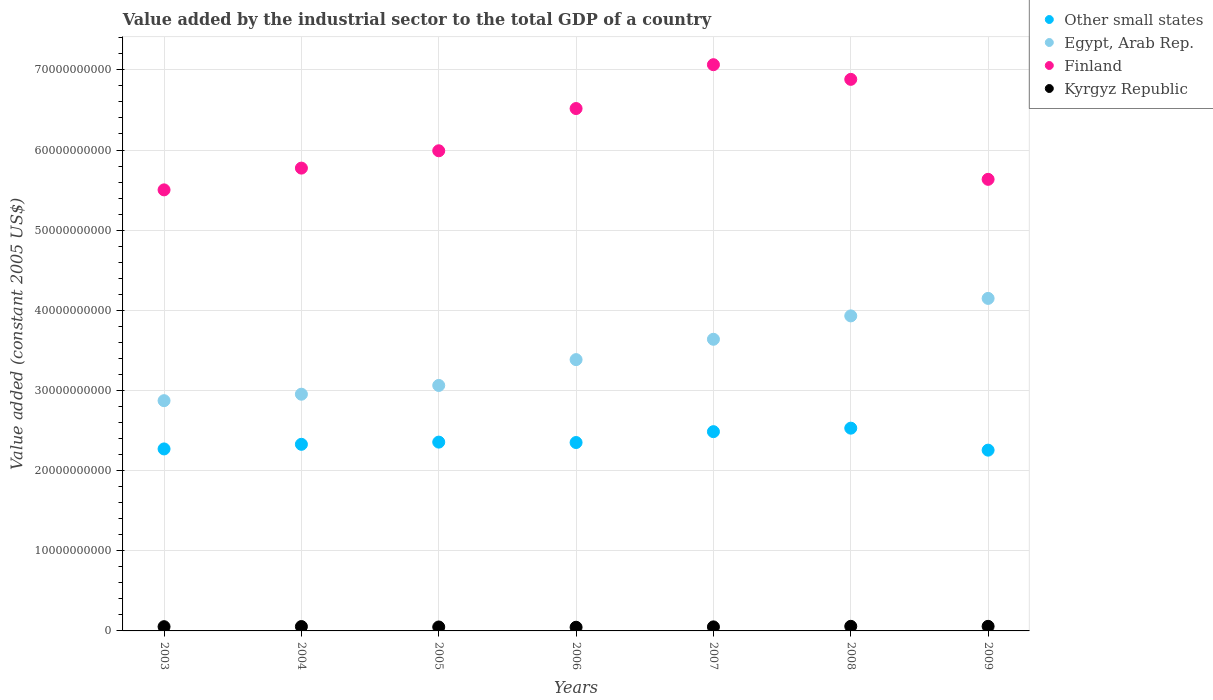How many different coloured dotlines are there?
Make the answer very short. 4. Is the number of dotlines equal to the number of legend labels?
Make the answer very short. Yes. What is the value added by the industrial sector in Other small states in 2008?
Offer a very short reply. 2.53e+1. Across all years, what is the maximum value added by the industrial sector in Other small states?
Offer a terse response. 2.53e+1. Across all years, what is the minimum value added by the industrial sector in Other small states?
Ensure brevity in your answer.  2.26e+1. What is the total value added by the industrial sector in Other small states in the graph?
Make the answer very short. 1.66e+11. What is the difference between the value added by the industrial sector in Egypt, Arab Rep. in 2003 and that in 2008?
Ensure brevity in your answer.  -1.06e+1. What is the difference between the value added by the industrial sector in Egypt, Arab Rep. in 2007 and the value added by the industrial sector in Finland in 2008?
Keep it short and to the point. -3.24e+1. What is the average value added by the industrial sector in Other small states per year?
Ensure brevity in your answer.  2.37e+1. In the year 2003, what is the difference between the value added by the industrial sector in Other small states and value added by the industrial sector in Finland?
Keep it short and to the point. -3.23e+1. In how many years, is the value added by the industrial sector in Other small states greater than 50000000000 US$?
Offer a very short reply. 0. What is the ratio of the value added by the industrial sector in Egypt, Arab Rep. in 2004 to that in 2007?
Your answer should be compact. 0.81. What is the difference between the highest and the second highest value added by the industrial sector in Egypt, Arab Rep.?
Your response must be concise. 2.18e+09. What is the difference between the highest and the lowest value added by the industrial sector in Finland?
Your answer should be compact. 1.56e+1. In how many years, is the value added by the industrial sector in Finland greater than the average value added by the industrial sector in Finland taken over all years?
Your response must be concise. 3. Is it the case that in every year, the sum of the value added by the industrial sector in Finland and value added by the industrial sector in Other small states  is greater than the sum of value added by the industrial sector in Egypt, Arab Rep. and value added by the industrial sector in Kyrgyz Republic?
Your answer should be very brief. No. Does the value added by the industrial sector in Other small states monotonically increase over the years?
Offer a very short reply. No. What is the difference between two consecutive major ticks on the Y-axis?
Offer a terse response. 1.00e+1. Are the values on the major ticks of Y-axis written in scientific E-notation?
Your answer should be very brief. No. Does the graph contain any zero values?
Give a very brief answer. No. Does the graph contain grids?
Keep it short and to the point. Yes. How are the legend labels stacked?
Your answer should be very brief. Vertical. What is the title of the graph?
Your response must be concise. Value added by the industrial sector to the total GDP of a country. What is the label or title of the X-axis?
Your response must be concise. Years. What is the label or title of the Y-axis?
Ensure brevity in your answer.  Value added (constant 2005 US$). What is the Value added (constant 2005 US$) of Other small states in 2003?
Offer a terse response. 2.27e+1. What is the Value added (constant 2005 US$) in Egypt, Arab Rep. in 2003?
Provide a short and direct response. 2.87e+1. What is the Value added (constant 2005 US$) of Finland in 2003?
Your answer should be compact. 5.50e+1. What is the Value added (constant 2005 US$) of Kyrgyz Republic in 2003?
Your response must be concise. 5.29e+08. What is the Value added (constant 2005 US$) of Other small states in 2004?
Your answer should be very brief. 2.33e+1. What is the Value added (constant 2005 US$) of Egypt, Arab Rep. in 2004?
Keep it short and to the point. 2.95e+1. What is the Value added (constant 2005 US$) of Finland in 2004?
Keep it short and to the point. 5.77e+1. What is the Value added (constant 2005 US$) in Kyrgyz Republic in 2004?
Ensure brevity in your answer.  5.45e+08. What is the Value added (constant 2005 US$) of Other small states in 2005?
Offer a very short reply. 2.36e+1. What is the Value added (constant 2005 US$) in Egypt, Arab Rep. in 2005?
Your response must be concise. 3.06e+1. What is the Value added (constant 2005 US$) of Finland in 2005?
Give a very brief answer. 5.99e+1. What is the Value added (constant 2005 US$) of Kyrgyz Republic in 2005?
Provide a succinct answer. 4.91e+08. What is the Value added (constant 2005 US$) of Other small states in 2006?
Offer a very short reply. 2.35e+1. What is the Value added (constant 2005 US$) in Egypt, Arab Rep. in 2006?
Your answer should be compact. 3.38e+1. What is the Value added (constant 2005 US$) of Finland in 2006?
Offer a terse response. 6.52e+1. What is the Value added (constant 2005 US$) of Kyrgyz Republic in 2006?
Make the answer very short. 4.57e+08. What is the Value added (constant 2005 US$) in Other small states in 2007?
Offer a terse response. 2.49e+1. What is the Value added (constant 2005 US$) in Egypt, Arab Rep. in 2007?
Offer a very short reply. 3.64e+1. What is the Value added (constant 2005 US$) of Finland in 2007?
Provide a short and direct response. 7.06e+1. What is the Value added (constant 2005 US$) in Kyrgyz Republic in 2007?
Provide a short and direct response. 5.04e+08. What is the Value added (constant 2005 US$) of Other small states in 2008?
Your answer should be compact. 2.53e+1. What is the Value added (constant 2005 US$) in Egypt, Arab Rep. in 2008?
Your response must be concise. 3.93e+1. What is the Value added (constant 2005 US$) in Finland in 2008?
Offer a terse response. 6.88e+1. What is the Value added (constant 2005 US$) in Kyrgyz Republic in 2008?
Provide a succinct answer. 5.74e+08. What is the Value added (constant 2005 US$) of Other small states in 2009?
Offer a terse response. 2.26e+1. What is the Value added (constant 2005 US$) in Egypt, Arab Rep. in 2009?
Keep it short and to the point. 4.15e+1. What is the Value added (constant 2005 US$) in Finland in 2009?
Your answer should be very brief. 5.63e+1. What is the Value added (constant 2005 US$) in Kyrgyz Republic in 2009?
Your answer should be compact. 5.72e+08. Across all years, what is the maximum Value added (constant 2005 US$) in Other small states?
Your answer should be very brief. 2.53e+1. Across all years, what is the maximum Value added (constant 2005 US$) in Egypt, Arab Rep.?
Provide a succinct answer. 4.15e+1. Across all years, what is the maximum Value added (constant 2005 US$) of Finland?
Your answer should be very brief. 7.06e+1. Across all years, what is the maximum Value added (constant 2005 US$) in Kyrgyz Republic?
Your response must be concise. 5.74e+08. Across all years, what is the minimum Value added (constant 2005 US$) in Other small states?
Your response must be concise. 2.26e+1. Across all years, what is the minimum Value added (constant 2005 US$) in Egypt, Arab Rep.?
Your answer should be compact. 2.87e+1. Across all years, what is the minimum Value added (constant 2005 US$) of Finland?
Provide a short and direct response. 5.50e+1. Across all years, what is the minimum Value added (constant 2005 US$) in Kyrgyz Republic?
Give a very brief answer. 4.57e+08. What is the total Value added (constant 2005 US$) of Other small states in the graph?
Make the answer very short. 1.66e+11. What is the total Value added (constant 2005 US$) in Egypt, Arab Rep. in the graph?
Ensure brevity in your answer.  2.40e+11. What is the total Value added (constant 2005 US$) in Finland in the graph?
Ensure brevity in your answer.  4.34e+11. What is the total Value added (constant 2005 US$) in Kyrgyz Republic in the graph?
Offer a terse response. 3.67e+09. What is the difference between the Value added (constant 2005 US$) in Other small states in 2003 and that in 2004?
Provide a succinct answer. -5.76e+08. What is the difference between the Value added (constant 2005 US$) in Egypt, Arab Rep. in 2003 and that in 2004?
Your answer should be very brief. -8.06e+08. What is the difference between the Value added (constant 2005 US$) of Finland in 2003 and that in 2004?
Your response must be concise. -2.71e+09. What is the difference between the Value added (constant 2005 US$) of Kyrgyz Republic in 2003 and that in 2004?
Provide a short and direct response. -1.61e+07. What is the difference between the Value added (constant 2005 US$) of Other small states in 2003 and that in 2005?
Offer a terse response. -8.50e+08. What is the difference between the Value added (constant 2005 US$) of Egypt, Arab Rep. in 2003 and that in 2005?
Provide a succinct answer. -1.90e+09. What is the difference between the Value added (constant 2005 US$) in Finland in 2003 and that in 2005?
Give a very brief answer. -4.88e+09. What is the difference between the Value added (constant 2005 US$) of Kyrgyz Republic in 2003 and that in 2005?
Provide a succinct answer. 3.76e+07. What is the difference between the Value added (constant 2005 US$) of Other small states in 2003 and that in 2006?
Make the answer very short. -7.98e+08. What is the difference between the Value added (constant 2005 US$) in Egypt, Arab Rep. in 2003 and that in 2006?
Your answer should be very brief. -5.12e+09. What is the difference between the Value added (constant 2005 US$) in Finland in 2003 and that in 2006?
Offer a terse response. -1.01e+1. What is the difference between the Value added (constant 2005 US$) of Kyrgyz Republic in 2003 and that in 2006?
Provide a succinct answer. 7.22e+07. What is the difference between the Value added (constant 2005 US$) of Other small states in 2003 and that in 2007?
Your answer should be very brief. -2.15e+09. What is the difference between the Value added (constant 2005 US$) of Egypt, Arab Rep. in 2003 and that in 2007?
Keep it short and to the point. -7.66e+09. What is the difference between the Value added (constant 2005 US$) in Finland in 2003 and that in 2007?
Provide a succinct answer. -1.56e+1. What is the difference between the Value added (constant 2005 US$) of Kyrgyz Republic in 2003 and that in 2007?
Make the answer very short. 2.52e+07. What is the difference between the Value added (constant 2005 US$) of Other small states in 2003 and that in 2008?
Give a very brief answer. -2.59e+09. What is the difference between the Value added (constant 2005 US$) in Egypt, Arab Rep. in 2003 and that in 2008?
Provide a short and direct response. -1.06e+1. What is the difference between the Value added (constant 2005 US$) in Finland in 2003 and that in 2008?
Give a very brief answer. -1.38e+1. What is the difference between the Value added (constant 2005 US$) in Kyrgyz Republic in 2003 and that in 2008?
Give a very brief answer. -4.51e+07. What is the difference between the Value added (constant 2005 US$) of Other small states in 2003 and that in 2009?
Provide a succinct answer. 1.52e+08. What is the difference between the Value added (constant 2005 US$) in Egypt, Arab Rep. in 2003 and that in 2009?
Ensure brevity in your answer.  -1.28e+1. What is the difference between the Value added (constant 2005 US$) of Finland in 2003 and that in 2009?
Give a very brief answer. -1.31e+09. What is the difference between the Value added (constant 2005 US$) in Kyrgyz Republic in 2003 and that in 2009?
Your answer should be compact. -4.33e+07. What is the difference between the Value added (constant 2005 US$) of Other small states in 2004 and that in 2005?
Ensure brevity in your answer.  -2.73e+08. What is the difference between the Value added (constant 2005 US$) of Egypt, Arab Rep. in 2004 and that in 2005?
Your answer should be compact. -1.09e+09. What is the difference between the Value added (constant 2005 US$) in Finland in 2004 and that in 2005?
Provide a succinct answer. -2.16e+09. What is the difference between the Value added (constant 2005 US$) in Kyrgyz Republic in 2004 and that in 2005?
Your answer should be compact. 5.37e+07. What is the difference between the Value added (constant 2005 US$) of Other small states in 2004 and that in 2006?
Provide a short and direct response. -2.22e+08. What is the difference between the Value added (constant 2005 US$) in Egypt, Arab Rep. in 2004 and that in 2006?
Your answer should be very brief. -4.32e+09. What is the difference between the Value added (constant 2005 US$) in Finland in 2004 and that in 2006?
Make the answer very short. -7.43e+09. What is the difference between the Value added (constant 2005 US$) in Kyrgyz Republic in 2004 and that in 2006?
Your answer should be compact. 8.83e+07. What is the difference between the Value added (constant 2005 US$) of Other small states in 2004 and that in 2007?
Keep it short and to the point. -1.58e+09. What is the difference between the Value added (constant 2005 US$) in Egypt, Arab Rep. in 2004 and that in 2007?
Your answer should be compact. -6.85e+09. What is the difference between the Value added (constant 2005 US$) of Finland in 2004 and that in 2007?
Make the answer very short. -1.29e+1. What is the difference between the Value added (constant 2005 US$) of Kyrgyz Republic in 2004 and that in 2007?
Provide a succinct answer. 4.13e+07. What is the difference between the Value added (constant 2005 US$) of Other small states in 2004 and that in 2008?
Your answer should be very brief. -2.01e+09. What is the difference between the Value added (constant 2005 US$) of Egypt, Arab Rep. in 2004 and that in 2008?
Make the answer very short. -9.77e+09. What is the difference between the Value added (constant 2005 US$) in Finland in 2004 and that in 2008?
Offer a terse response. -1.11e+1. What is the difference between the Value added (constant 2005 US$) of Kyrgyz Republic in 2004 and that in 2008?
Offer a very short reply. -2.90e+07. What is the difference between the Value added (constant 2005 US$) of Other small states in 2004 and that in 2009?
Your response must be concise. 7.29e+08. What is the difference between the Value added (constant 2005 US$) of Egypt, Arab Rep. in 2004 and that in 2009?
Offer a very short reply. -1.20e+1. What is the difference between the Value added (constant 2005 US$) in Finland in 2004 and that in 2009?
Make the answer very short. 1.40e+09. What is the difference between the Value added (constant 2005 US$) of Kyrgyz Republic in 2004 and that in 2009?
Ensure brevity in your answer.  -2.72e+07. What is the difference between the Value added (constant 2005 US$) of Other small states in 2005 and that in 2006?
Keep it short and to the point. 5.14e+07. What is the difference between the Value added (constant 2005 US$) of Egypt, Arab Rep. in 2005 and that in 2006?
Provide a succinct answer. -3.22e+09. What is the difference between the Value added (constant 2005 US$) of Finland in 2005 and that in 2006?
Provide a short and direct response. -5.27e+09. What is the difference between the Value added (constant 2005 US$) of Kyrgyz Republic in 2005 and that in 2006?
Your answer should be compact. 3.46e+07. What is the difference between the Value added (constant 2005 US$) of Other small states in 2005 and that in 2007?
Your answer should be very brief. -1.30e+09. What is the difference between the Value added (constant 2005 US$) in Egypt, Arab Rep. in 2005 and that in 2007?
Offer a very short reply. -5.76e+09. What is the difference between the Value added (constant 2005 US$) in Finland in 2005 and that in 2007?
Your answer should be very brief. -1.07e+1. What is the difference between the Value added (constant 2005 US$) of Kyrgyz Republic in 2005 and that in 2007?
Your answer should be very brief. -1.24e+07. What is the difference between the Value added (constant 2005 US$) in Other small states in 2005 and that in 2008?
Make the answer very short. -1.74e+09. What is the difference between the Value added (constant 2005 US$) of Egypt, Arab Rep. in 2005 and that in 2008?
Make the answer very short. -8.68e+09. What is the difference between the Value added (constant 2005 US$) of Finland in 2005 and that in 2008?
Keep it short and to the point. -8.91e+09. What is the difference between the Value added (constant 2005 US$) of Kyrgyz Republic in 2005 and that in 2008?
Your answer should be very brief. -8.27e+07. What is the difference between the Value added (constant 2005 US$) in Other small states in 2005 and that in 2009?
Provide a short and direct response. 1.00e+09. What is the difference between the Value added (constant 2005 US$) in Egypt, Arab Rep. in 2005 and that in 2009?
Give a very brief answer. -1.09e+1. What is the difference between the Value added (constant 2005 US$) in Finland in 2005 and that in 2009?
Make the answer very short. 3.56e+09. What is the difference between the Value added (constant 2005 US$) of Kyrgyz Republic in 2005 and that in 2009?
Your response must be concise. -8.08e+07. What is the difference between the Value added (constant 2005 US$) of Other small states in 2006 and that in 2007?
Offer a very short reply. -1.36e+09. What is the difference between the Value added (constant 2005 US$) of Egypt, Arab Rep. in 2006 and that in 2007?
Keep it short and to the point. -2.54e+09. What is the difference between the Value added (constant 2005 US$) of Finland in 2006 and that in 2007?
Provide a short and direct response. -5.47e+09. What is the difference between the Value added (constant 2005 US$) in Kyrgyz Republic in 2006 and that in 2007?
Provide a short and direct response. -4.70e+07. What is the difference between the Value added (constant 2005 US$) of Other small states in 2006 and that in 2008?
Provide a short and direct response. -1.79e+09. What is the difference between the Value added (constant 2005 US$) in Egypt, Arab Rep. in 2006 and that in 2008?
Provide a short and direct response. -5.46e+09. What is the difference between the Value added (constant 2005 US$) of Finland in 2006 and that in 2008?
Your answer should be very brief. -3.64e+09. What is the difference between the Value added (constant 2005 US$) of Kyrgyz Republic in 2006 and that in 2008?
Give a very brief answer. -1.17e+08. What is the difference between the Value added (constant 2005 US$) of Other small states in 2006 and that in 2009?
Give a very brief answer. 9.50e+08. What is the difference between the Value added (constant 2005 US$) in Egypt, Arab Rep. in 2006 and that in 2009?
Offer a very short reply. -7.64e+09. What is the difference between the Value added (constant 2005 US$) in Finland in 2006 and that in 2009?
Make the answer very short. 8.83e+09. What is the difference between the Value added (constant 2005 US$) of Kyrgyz Republic in 2006 and that in 2009?
Your answer should be very brief. -1.15e+08. What is the difference between the Value added (constant 2005 US$) of Other small states in 2007 and that in 2008?
Provide a succinct answer. -4.36e+08. What is the difference between the Value added (constant 2005 US$) in Egypt, Arab Rep. in 2007 and that in 2008?
Provide a succinct answer. -2.92e+09. What is the difference between the Value added (constant 2005 US$) of Finland in 2007 and that in 2008?
Offer a terse response. 1.83e+09. What is the difference between the Value added (constant 2005 US$) of Kyrgyz Republic in 2007 and that in 2008?
Offer a terse response. -7.03e+07. What is the difference between the Value added (constant 2005 US$) of Other small states in 2007 and that in 2009?
Make the answer very short. 2.31e+09. What is the difference between the Value added (constant 2005 US$) of Egypt, Arab Rep. in 2007 and that in 2009?
Provide a succinct answer. -5.10e+09. What is the difference between the Value added (constant 2005 US$) in Finland in 2007 and that in 2009?
Offer a terse response. 1.43e+1. What is the difference between the Value added (constant 2005 US$) in Kyrgyz Republic in 2007 and that in 2009?
Your answer should be very brief. -6.85e+07. What is the difference between the Value added (constant 2005 US$) of Other small states in 2008 and that in 2009?
Your response must be concise. 2.74e+09. What is the difference between the Value added (constant 2005 US$) of Egypt, Arab Rep. in 2008 and that in 2009?
Your answer should be very brief. -2.18e+09. What is the difference between the Value added (constant 2005 US$) of Finland in 2008 and that in 2009?
Keep it short and to the point. 1.25e+1. What is the difference between the Value added (constant 2005 US$) of Kyrgyz Republic in 2008 and that in 2009?
Ensure brevity in your answer.  1.82e+06. What is the difference between the Value added (constant 2005 US$) of Other small states in 2003 and the Value added (constant 2005 US$) of Egypt, Arab Rep. in 2004?
Offer a very short reply. -6.83e+09. What is the difference between the Value added (constant 2005 US$) of Other small states in 2003 and the Value added (constant 2005 US$) of Finland in 2004?
Offer a terse response. -3.50e+1. What is the difference between the Value added (constant 2005 US$) of Other small states in 2003 and the Value added (constant 2005 US$) of Kyrgyz Republic in 2004?
Offer a very short reply. 2.22e+1. What is the difference between the Value added (constant 2005 US$) of Egypt, Arab Rep. in 2003 and the Value added (constant 2005 US$) of Finland in 2004?
Offer a terse response. -2.90e+1. What is the difference between the Value added (constant 2005 US$) in Egypt, Arab Rep. in 2003 and the Value added (constant 2005 US$) in Kyrgyz Republic in 2004?
Offer a terse response. 2.82e+1. What is the difference between the Value added (constant 2005 US$) of Finland in 2003 and the Value added (constant 2005 US$) of Kyrgyz Republic in 2004?
Give a very brief answer. 5.45e+1. What is the difference between the Value added (constant 2005 US$) of Other small states in 2003 and the Value added (constant 2005 US$) of Egypt, Arab Rep. in 2005?
Ensure brevity in your answer.  -7.92e+09. What is the difference between the Value added (constant 2005 US$) in Other small states in 2003 and the Value added (constant 2005 US$) in Finland in 2005?
Ensure brevity in your answer.  -3.72e+1. What is the difference between the Value added (constant 2005 US$) of Other small states in 2003 and the Value added (constant 2005 US$) of Kyrgyz Republic in 2005?
Provide a short and direct response. 2.22e+1. What is the difference between the Value added (constant 2005 US$) in Egypt, Arab Rep. in 2003 and the Value added (constant 2005 US$) in Finland in 2005?
Your answer should be compact. -3.12e+1. What is the difference between the Value added (constant 2005 US$) in Egypt, Arab Rep. in 2003 and the Value added (constant 2005 US$) in Kyrgyz Republic in 2005?
Provide a succinct answer. 2.82e+1. What is the difference between the Value added (constant 2005 US$) of Finland in 2003 and the Value added (constant 2005 US$) of Kyrgyz Republic in 2005?
Make the answer very short. 5.45e+1. What is the difference between the Value added (constant 2005 US$) in Other small states in 2003 and the Value added (constant 2005 US$) in Egypt, Arab Rep. in 2006?
Your response must be concise. -1.11e+1. What is the difference between the Value added (constant 2005 US$) in Other small states in 2003 and the Value added (constant 2005 US$) in Finland in 2006?
Ensure brevity in your answer.  -4.25e+1. What is the difference between the Value added (constant 2005 US$) of Other small states in 2003 and the Value added (constant 2005 US$) of Kyrgyz Republic in 2006?
Offer a very short reply. 2.23e+1. What is the difference between the Value added (constant 2005 US$) in Egypt, Arab Rep. in 2003 and the Value added (constant 2005 US$) in Finland in 2006?
Your answer should be very brief. -3.64e+1. What is the difference between the Value added (constant 2005 US$) of Egypt, Arab Rep. in 2003 and the Value added (constant 2005 US$) of Kyrgyz Republic in 2006?
Your answer should be compact. 2.83e+1. What is the difference between the Value added (constant 2005 US$) of Finland in 2003 and the Value added (constant 2005 US$) of Kyrgyz Republic in 2006?
Offer a very short reply. 5.46e+1. What is the difference between the Value added (constant 2005 US$) in Other small states in 2003 and the Value added (constant 2005 US$) in Egypt, Arab Rep. in 2007?
Make the answer very short. -1.37e+1. What is the difference between the Value added (constant 2005 US$) in Other small states in 2003 and the Value added (constant 2005 US$) in Finland in 2007?
Keep it short and to the point. -4.79e+1. What is the difference between the Value added (constant 2005 US$) in Other small states in 2003 and the Value added (constant 2005 US$) in Kyrgyz Republic in 2007?
Make the answer very short. 2.22e+1. What is the difference between the Value added (constant 2005 US$) of Egypt, Arab Rep. in 2003 and the Value added (constant 2005 US$) of Finland in 2007?
Keep it short and to the point. -4.19e+1. What is the difference between the Value added (constant 2005 US$) in Egypt, Arab Rep. in 2003 and the Value added (constant 2005 US$) in Kyrgyz Republic in 2007?
Your answer should be very brief. 2.82e+1. What is the difference between the Value added (constant 2005 US$) of Finland in 2003 and the Value added (constant 2005 US$) of Kyrgyz Republic in 2007?
Provide a succinct answer. 5.45e+1. What is the difference between the Value added (constant 2005 US$) in Other small states in 2003 and the Value added (constant 2005 US$) in Egypt, Arab Rep. in 2008?
Give a very brief answer. -1.66e+1. What is the difference between the Value added (constant 2005 US$) in Other small states in 2003 and the Value added (constant 2005 US$) in Finland in 2008?
Make the answer very short. -4.61e+1. What is the difference between the Value added (constant 2005 US$) of Other small states in 2003 and the Value added (constant 2005 US$) of Kyrgyz Republic in 2008?
Your answer should be very brief. 2.21e+1. What is the difference between the Value added (constant 2005 US$) of Egypt, Arab Rep. in 2003 and the Value added (constant 2005 US$) of Finland in 2008?
Your answer should be very brief. -4.01e+1. What is the difference between the Value added (constant 2005 US$) of Egypt, Arab Rep. in 2003 and the Value added (constant 2005 US$) of Kyrgyz Republic in 2008?
Ensure brevity in your answer.  2.82e+1. What is the difference between the Value added (constant 2005 US$) of Finland in 2003 and the Value added (constant 2005 US$) of Kyrgyz Republic in 2008?
Ensure brevity in your answer.  5.45e+1. What is the difference between the Value added (constant 2005 US$) of Other small states in 2003 and the Value added (constant 2005 US$) of Egypt, Arab Rep. in 2009?
Offer a terse response. -1.88e+1. What is the difference between the Value added (constant 2005 US$) in Other small states in 2003 and the Value added (constant 2005 US$) in Finland in 2009?
Your response must be concise. -3.36e+1. What is the difference between the Value added (constant 2005 US$) of Other small states in 2003 and the Value added (constant 2005 US$) of Kyrgyz Republic in 2009?
Make the answer very short. 2.21e+1. What is the difference between the Value added (constant 2005 US$) of Egypt, Arab Rep. in 2003 and the Value added (constant 2005 US$) of Finland in 2009?
Offer a very short reply. -2.76e+1. What is the difference between the Value added (constant 2005 US$) of Egypt, Arab Rep. in 2003 and the Value added (constant 2005 US$) of Kyrgyz Republic in 2009?
Give a very brief answer. 2.82e+1. What is the difference between the Value added (constant 2005 US$) in Finland in 2003 and the Value added (constant 2005 US$) in Kyrgyz Republic in 2009?
Keep it short and to the point. 5.45e+1. What is the difference between the Value added (constant 2005 US$) in Other small states in 2004 and the Value added (constant 2005 US$) in Egypt, Arab Rep. in 2005?
Provide a succinct answer. -7.34e+09. What is the difference between the Value added (constant 2005 US$) of Other small states in 2004 and the Value added (constant 2005 US$) of Finland in 2005?
Ensure brevity in your answer.  -3.66e+1. What is the difference between the Value added (constant 2005 US$) of Other small states in 2004 and the Value added (constant 2005 US$) of Kyrgyz Republic in 2005?
Keep it short and to the point. 2.28e+1. What is the difference between the Value added (constant 2005 US$) of Egypt, Arab Rep. in 2004 and the Value added (constant 2005 US$) of Finland in 2005?
Your answer should be very brief. -3.04e+1. What is the difference between the Value added (constant 2005 US$) of Egypt, Arab Rep. in 2004 and the Value added (constant 2005 US$) of Kyrgyz Republic in 2005?
Provide a short and direct response. 2.90e+1. What is the difference between the Value added (constant 2005 US$) of Finland in 2004 and the Value added (constant 2005 US$) of Kyrgyz Republic in 2005?
Ensure brevity in your answer.  5.73e+1. What is the difference between the Value added (constant 2005 US$) in Other small states in 2004 and the Value added (constant 2005 US$) in Egypt, Arab Rep. in 2006?
Ensure brevity in your answer.  -1.06e+1. What is the difference between the Value added (constant 2005 US$) in Other small states in 2004 and the Value added (constant 2005 US$) in Finland in 2006?
Provide a short and direct response. -4.19e+1. What is the difference between the Value added (constant 2005 US$) of Other small states in 2004 and the Value added (constant 2005 US$) of Kyrgyz Republic in 2006?
Your answer should be compact. 2.28e+1. What is the difference between the Value added (constant 2005 US$) of Egypt, Arab Rep. in 2004 and the Value added (constant 2005 US$) of Finland in 2006?
Provide a short and direct response. -3.56e+1. What is the difference between the Value added (constant 2005 US$) in Egypt, Arab Rep. in 2004 and the Value added (constant 2005 US$) in Kyrgyz Republic in 2006?
Keep it short and to the point. 2.91e+1. What is the difference between the Value added (constant 2005 US$) of Finland in 2004 and the Value added (constant 2005 US$) of Kyrgyz Republic in 2006?
Provide a succinct answer. 5.73e+1. What is the difference between the Value added (constant 2005 US$) in Other small states in 2004 and the Value added (constant 2005 US$) in Egypt, Arab Rep. in 2007?
Offer a very short reply. -1.31e+1. What is the difference between the Value added (constant 2005 US$) of Other small states in 2004 and the Value added (constant 2005 US$) of Finland in 2007?
Your answer should be very brief. -4.74e+1. What is the difference between the Value added (constant 2005 US$) of Other small states in 2004 and the Value added (constant 2005 US$) of Kyrgyz Republic in 2007?
Give a very brief answer. 2.28e+1. What is the difference between the Value added (constant 2005 US$) in Egypt, Arab Rep. in 2004 and the Value added (constant 2005 US$) in Finland in 2007?
Offer a terse response. -4.11e+1. What is the difference between the Value added (constant 2005 US$) of Egypt, Arab Rep. in 2004 and the Value added (constant 2005 US$) of Kyrgyz Republic in 2007?
Ensure brevity in your answer.  2.90e+1. What is the difference between the Value added (constant 2005 US$) of Finland in 2004 and the Value added (constant 2005 US$) of Kyrgyz Republic in 2007?
Your answer should be compact. 5.72e+1. What is the difference between the Value added (constant 2005 US$) of Other small states in 2004 and the Value added (constant 2005 US$) of Egypt, Arab Rep. in 2008?
Make the answer very short. -1.60e+1. What is the difference between the Value added (constant 2005 US$) in Other small states in 2004 and the Value added (constant 2005 US$) in Finland in 2008?
Ensure brevity in your answer.  -4.55e+1. What is the difference between the Value added (constant 2005 US$) of Other small states in 2004 and the Value added (constant 2005 US$) of Kyrgyz Republic in 2008?
Give a very brief answer. 2.27e+1. What is the difference between the Value added (constant 2005 US$) of Egypt, Arab Rep. in 2004 and the Value added (constant 2005 US$) of Finland in 2008?
Ensure brevity in your answer.  -3.93e+1. What is the difference between the Value added (constant 2005 US$) in Egypt, Arab Rep. in 2004 and the Value added (constant 2005 US$) in Kyrgyz Republic in 2008?
Provide a short and direct response. 2.90e+1. What is the difference between the Value added (constant 2005 US$) in Finland in 2004 and the Value added (constant 2005 US$) in Kyrgyz Republic in 2008?
Give a very brief answer. 5.72e+1. What is the difference between the Value added (constant 2005 US$) of Other small states in 2004 and the Value added (constant 2005 US$) of Egypt, Arab Rep. in 2009?
Your response must be concise. -1.82e+1. What is the difference between the Value added (constant 2005 US$) in Other small states in 2004 and the Value added (constant 2005 US$) in Finland in 2009?
Give a very brief answer. -3.31e+1. What is the difference between the Value added (constant 2005 US$) in Other small states in 2004 and the Value added (constant 2005 US$) in Kyrgyz Republic in 2009?
Your answer should be compact. 2.27e+1. What is the difference between the Value added (constant 2005 US$) of Egypt, Arab Rep. in 2004 and the Value added (constant 2005 US$) of Finland in 2009?
Make the answer very short. -2.68e+1. What is the difference between the Value added (constant 2005 US$) in Egypt, Arab Rep. in 2004 and the Value added (constant 2005 US$) in Kyrgyz Republic in 2009?
Give a very brief answer. 2.90e+1. What is the difference between the Value added (constant 2005 US$) of Finland in 2004 and the Value added (constant 2005 US$) of Kyrgyz Republic in 2009?
Your answer should be very brief. 5.72e+1. What is the difference between the Value added (constant 2005 US$) of Other small states in 2005 and the Value added (constant 2005 US$) of Egypt, Arab Rep. in 2006?
Your response must be concise. -1.03e+1. What is the difference between the Value added (constant 2005 US$) in Other small states in 2005 and the Value added (constant 2005 US$) in Finland in 2006?
Ensure brevity in your answer.  -4.16e+1. What is the difference between the Value added (constant 2005 US$) of Other small states in 2005 and the Value added (constant 2005 US$) of Kyrgyz Republic in 2006?
Your answer should be very brief. 2.31e+1. What is the difference between the Value added (constant 2005 US$) of Egypt, Arab Rep. in 2005 and the Value added (constant 2005 US$) of Finland in 2006?
Offer a terse response. -3.45e+1. What is the difference between the Value added (constant 2005 US$) of Egypt, Arab Rep. in 2005 and the Value added (constant 2005 US$) of Kyrgyz Republic in 2006?
Keep it short and to the point. 3.02e+1. What is the difference between the Value added (constant 2005 US$) of Finland in 2005 and the Value added (constant 2005 US$) of Kyrgyz Republic in 2006?
Your answer should be very brief. 5.94e+1. What is the difference between the Value added (constant 2005 US$) of Other small states in 2005 and the Value added (constant 2005 US$) of Egypt, Arab Rep. in 2007?
Your response must be concise. -1.28e+1. What is the difference between the Value added (constant 2005 US$) in Other small states in 2005 and the Value added (constant 2005 US$) in Finland in 2007?
Your response must be concise. -4.71e+1. What is the difference between the Value added (constant 2005 US$) in Other small states in 2005 and the Value added (constant 2005 US$) in Kyrgyz Republic in 2007?
Make the answer very short. 2.31e+1. What is the difference between the Value added (constant 2005 US$) in Egypt, Arab Rep. in 2005 and the Value added (constant 2005 US$) in Finland in 2007?
Your answer should be very brief. -4.00e+1. What is the difference between the Value added (constant 2005 US$) in Egypt, Arab Rep. in 2005 and the Value added (constant 2005 US$) in Kyrgyz Republic in 2007?
Offer a very short reply. 3.01e+1. What is the difference between the Value added (constant 2005 US$) of Finland in 2005 and the Value added (constant 2005 US$) of Kyrgyz Republic in 2007?
Provide a short and direct response. 5.94e+1. What is the difference between the Value added (constant 2005 US$) in Other small states in 2005 and the Value added (constant 2005 US$) in Egypt, Arab Rep. in 2008?
Provide a succinct answer. -1.57e+1. What is the difference between the Value added (constant 2005 US$) of Other small states in 2005 and the Value added (constant 2005 US$) of Finland in 2008?
Ensure brevity in your answer.  -4.53e+1. What is the difference between the Value added (constant 2005 US$) of Other small states in 2005 and the Value added (constant 2005 US$) of Kyrgyz Republic in 2008?
Offer a very short reply. 2.30e+1. What is the difference between the Value added (constant 2005 US$) of Egypt, Arab Rep. in 2005 and the Value added (constant 2005 US$) of Finland in 2008?
Provide a succinct answer. -3.82e+1. What is the difference between the Value added (constant 2005 US$) of Egypt, Arab Rep. in 2005 and the Value added (constant 2005 US$) of Kyrgyz Republic in 2008?
Your answer should be very brief. 3.01e+1. What is the difference between the Value added (constant 2005 US$) of Finland in 2005 and the Value added (constant 2005 US$) of Kyrgyz Republic in 2008?
Your answer should be compact. 5.93e+1. What is the difference between the Value added (constant 2005 US$) of Other small states in 2005 and the Value added (constant 2005 US$) of Egypt, Arab Rep. in 2009?
Provide a succinct answer. -1.79e+1. What is the difference between the Value added (constant 2005 US$) of Other small states in 2005 and the Value added (constant 2005 US$) of Finland in 2009?
Keep it short and to the point. -3.28e+1. What is the difference between the Value added (constant 2005 US$) in Other small states in 2005 and the Value added (constant 2005 US$) in Kyrgyz Republic in 2009?
Give a very brief answer. 2.30e+1. What is the difference between the Value added (constant 2005 US$) of Egypt, Arab Rep. in 2005 and the Value added (constant 2005 US$) of Finland in 2009?
Your answer should be compact. -2.57e+1. What is the difference between the Value added (constant 2005 US$) of Egypt, Arab Rep. in 2005 and the Value added (constant 2005 US$) of Kyrgyz Republic in 2009?
Your answer should be very brief. 3.01e+1. What is the difference between the Value added (constant 2005 US$) of Finland in 2005 and the Value added (constant 2005 US$) of Kyrgyz Republic in 2009?
Offer a very short reply. 5.93e+1. What is the difference between the Value added (constant 2005 US$) in Other small states in 2006 and the Value added (constant 2005 US$) in Egypt, Arab Rep. in 2007?
Your response must be concise. -1.29e+1. What is the difference between the Value added (constant 2005 US$) of Other small states in 2006 and the Value added (constant 2005 US$) of Finland in 2007?
Your answer should be very brief. -4.71e+1. What is the difference between the Value added (constant 2005 US$) in Other small states in 2006 and the Value added (constant 2005 US$) in Kyrgyz Republic in 2007?
Make the answer very short. 2.30e+1. What is the difference between the Value added (constant 2005 US$) in Egypt, Arab Rep. in 2006 and the Value added (constant 2005 US$) in Finland in 2007?
Provide a succinct answer. -3.68e+1. What is the difference between the Value added (constant 2005 US$) of Egypt, Arab Rep. in 2006 and the Value added (constant 2005 US$) of Kyrgyz Republic in 2007?
Give a very brief answer. 3.33e+1. What is the difference between the Value added (constant 2005 US$) of Finland in 2006 and the Value added (constant 2005 US$) of Kyrgyz Republic in 2007?
Ensure brevity in your answer.  6.47e+1. What is the difference between the Value added (constant 2005 US$) in Other small states in 2006 and the Value added (constant 2005 US$) in Egypt, Arab Rep. in 2008?
Offer a terse response. -1.58e+1. What is the difference between the Value added (constant 2005 US$) of Other small states in 2006 and the Value added (constant 2005 US$) of Finland in 2008?
Keep it short and to the point. -4.53e+1. What is the difference between the Value added (constant 2005 US$) of Other small states in 2006 and the Value added (constant 2005 US$) of Kyrgyz Republic in 2008?
Keep it short and to the point. 2.29e+1. What is the difference between the Value added (constant 2005 US$) in Egypt, Arab Rep. in 2006 and the Value added (constant 2005 US$) in Finland in 2008?
Ensure brevity in your answer.  -3.50e+1. What is the difference between the Value added (constant 2005 US$) of Egypt, Arab Rep. in 2006 and the Value added (constant 2005 US$) of Kyrgyz Republic in 2008?
Keep it short and to the point. 3.33e+1. What is the difference between the Value added (constant 2005 US$) in Finland in 2006 and the Value added (constant 2005 US$) in Kyrgyz Republic in 2008?
Your answer should be compact. 6.46e+1. What is the difference between the Value added (constant 2005 US$) of Other small states in 2006 and the Value added (constant 2005 US$) of Egypt, Arab Rep. in 2009?
Offer a very short reply. -1.80e+1. What is the difference between the Value added (constant 2005 US$) in Other small states in 2006 and the Value added (constant 2005 US$) in Finland in 2009?
Your response must be concise. -3.28e+1. What is the difference between the Value added (constant 2005 US$) of Other small states in 2006 and the Value added (constant 2005 US$) of Kyrgyz Republic in 2009?
Provide a short and direct response. 2.29e+1. What is the difference between the Value added (constant 2005 US$) of Egypt, Arab Rep. in 2006 and the Value added (constant 2005 US$) of Finland in 2009?
Offer a terse response. -2.25e+1. What is the difference between the Value added (constant 2005 US$) of Egypt, Arab Rep. in 2006 and the Value added (constant 2005 US$) of Kyrgyz Republic in 2009?
Your answer should be compact. 3.33e+1. What is the difference between the Value added (constant 2005 US$) in Finland in 2006 and the Value added (constant 2005 US$) in Kyrgyz Republic in 2009?
Offer a very short reply. 6.46e+1. What is the difference between the Value added (constant 2005 US$) in Other small states in 2007 and the Value added (constant 2005 US$) in Egypt, Arab Rep. in 2008?
Give a very brief answer. -1.44e+1. What is the difference between the Value added (constant 2005 US$) in Other small states in 2007 and the Value added (constant 2005 US$) in Finland in 2008?
Ensure brevity in your answer.  -4.40e+1. What is the difference between the Value added (constant 2005 US$) of Other small states in 2007 and the Value added (constant 2005 US$) of Kyrgyz Republic in 2008?
Your answer should be compact. 2.43e+1. What is the difference between the Value added (constant 2005 US$) of Egypt, Arab Rep. in 2007 and the Value added (constant 2005 US$) of Finland in 2008?
Keep it short and to the point. -3.24e+1. What is the difference between the Value added (constant 2005 US$) in Egypt, Arab Rep. in 2007 and the Value added (constant 2005 US$) in Kyrgyz Republic in 2008?
Provide a succinct answer. 3.58e+1. What is the difference between the Value added (constant 2005 US$) of Finland in 2007 and the Value added (constant 2005 US$) of Kyrgyz Republic in 2008?
Offer a very short reply. 7.01e+1. What is the difference between the Value added (constant 2005 US$) in Other small states in 2007 and the Value added (constant 2005 US$) in Egypt, Arab Rep. in 2009?
Your response must be concise. -1.66e+1. What is the difference between the Value added (constant 2005 US$) of Other small states in 2007 and the Value added (constant 2005 US$) of Finland in 2009?
Provide a short and direct response. -3.15e+1. What is the difference between the Value added (constant 2005 US$) in Other small states in 2007 and the Value added (constant 2005 US$) in Kyrgyz Republic in 2009?
Keep it short and to the point. 2.43e+1. What is the difference between the Value added (constant 2005 US$) of Egypt, Arab Rep. in 2007 and the Value added (constant 2005 US$) of Finland in 2009?
Provide a short and direct response. -2.00e+1. What is the difference between the Value added (constant 2005 US$) in Egypt, Arab Rep. in 2007 and the Value added (constant 2005 US$) in Kyrgyz Republic in 2009?
Offer a very short reply. 3.58e+1. What is the difference between the Value added (constant 2005 US$) in Finland in 2007 and the Value added (constant 2005 US$) in Kyrgyz Republic in 2009?
Your response must be concise. 7.01e+1. What is the difference between the Value added (constant 2005 US$) in Other small states in 2008 and the Value added (constant 2005 US$) in Egypt, Arab Rep. in 2009?
Your answer should be compact. -1.62e+1. What is the difference between the Value added (constant 2005 US$) in Other small states in 2008 and the Value added (constant 2005 US$) in Finland in 2009?
Keep it short and to the point. -3.10e+1. What is the difference between the Value added (constant 2005 US$) of Other small states in 2008 and the Value added (constant 2005 US$) of Kyrgyz Republic in 2009?
Your response must be concise. 2.47e+1. What is the difference between the Value added (constant 2005 US$) in Egypt, Arab Rep. in 2008 and the Value added (constant 2005 US$) in Finland in 2009?
Provide a short and direct response. -1.70e+1. What is the difference between the Value added (constant 2005 US$) of Egypt, Arab Rep. in 2008 and the Value added (constant 2005 US$) of Kyrgyz Republic in 2009?
Your response must be concise. 3.87e+1. What is the difference between the Value added (constant 2005 US$) in Finland in 2008 and the Value added (constant 2005 US$) in Kyrgyz Republic in 2009?
Your answer should be very brief. 6.82e+1. What is the average Value added (constant 2005 US$) in Other small states per year?
Provide a short and direct response. 2.37e+1. What is the average Value added (constant 2005 US$) of Egypt, Arab Rep. per year?
Keep it short and to the point. 3.43e+1. What is the average Value added (constant 2005 US$) of Finland per year?
Ensure brevity in your answer.  6.20e+1. What is the average Value added (constant 2005 US$) in Kyrgyz Republic per year?
Offer a very short reply. 5.24e+08. In the year 2003, what is the difference between the Value added (constant 2005 US$) of Other small states and Value added (constant 2005 US$) of Egypt, Arab Rep.?
Your response must be concise. -6.02e+09. In the year 2003, what is the difference between the Value added (constant 2005 US$) of Other small states and Value added (constant 2005 US$) of Finland?
Offer a very short reply. -3.23e+1. In the year 2003, what is the difference between the Value added (constant 2005 US$) in Other small states and Value added (constant 2005 US$) in Kyrgyz Republic?
Your answer should be compact. 2.22e+1. In the year 2003, what is the difference between the Value added (constant 2005 US$) in Egypt, Arab Rep. and Value added (constant 2005 US$) in Finland?
Your answer should be compact. -2.63e+1. In the year 2003, what is the difference between the Value added (constant 2005 US$) of Egypt, Arab Rep. and Value added (constant 2005 US$) of Kyrgyz Republic?
Keep it short and to the point. 2.82e+1. In the year 2003, what is the difference between the Value added (constant 2005 US$) in Finland and Value added (constant 2005 US$) in Kyrgyz Republic?
Give a very brief answer. 5.45e+1. In the year 2004, what is the difference between the Value added (constant 2005 US$) in Other small states and Value added (constant 2005 US$) in Egypt, Arab Rep.?
Your answer should be compact. -6.25e+09. In the year 2004, what is the difference between the Value added (constant 2005 US$) of Other small states and Value added (constant 2005 US$) of Finland?
Keep it short and to the point. -3.45e+1. In the year 2004, what is the difference between the Value added (constant 2005 US$) in Other small states and Value added (constant 2005 US$) in Kyrgyz Republic?
Provide a succinct answer. 2.27e+1. In the year 2004, what is the difference between the Value added (constant 2005 US$) in Egypt, Arab Rep. and Value added (constant 2005 US$) in Finland?
Give a very brief answer. -2.82e+1. In the year 2004, what is the difference between the Value added (constant 2005 US$) of Egypt, Arab Rep. and Value added (constant 2005 US$) of Kyrgyz Republic?
Make the answer very short. 2.90e+1. In the year 2004, what is the difference between the Value added (constant 2005 US$) of Finland and Value added (constant 2005 US$) of Kyrgyz Republic?
Ensure brevity in your answer.  5.72e+1. In the year 2005, what is the difference between the Value added (constant 2005 US$) of Other small states and Value added (constant 2005 US$) of Egypt, Arab Rep.?
Ensure brevity in your answer.  -7.07e+09. In the year 2005, what is the difference between the Value added (constant 2005 US$) of Other small states and Value added (constant 2005 US$) of Finland?
Provide a succinct answer. -3.63e+1. In the year 2005, what is the difference between the Value added (constant 2005 US$) in Other small states and Value added (constant 2005 US$) in Kyrgyz Republic?
Offer a very short reply. 2.31e+1. In the year 2005, what is the difference between the Value added (constant 2005 US$) in Egypt, Arab Rep. and Value added (constant 2005 US$) in Finland?
Provide a short and direct response. -2.93e+1. In the year 2005, what is the difference between the Value added (constant 2005 US$) in Egypt, Arab Rep. and Value added (constant 2005 US$) in Kyrgyz Republic?
Offer a very short reply. 3.01e+1. In the year 2005, what is the difference between the Value added (constant 2005 US$) in Finland and Value added (constant 2005 US$) in Kyrgyz Republic?
Your answer should be very brief. 5.94e+1. In the year 2006, what is the difference between the Value added (constant 2005 US$) of Other small states and Value added (constant 2005 US$) of Egypt, Arab Rep.?
Keep it short and to the point. -1.03e+1. In the year 2006, what is the difference between the Value added (constant 2005 US$) of Other small states and Value added (constant 2005 US$) of Finland?
Keep it short and to the point. -4.17e+1. In the year 2006, what is the difference between the Value added (constant 2005 US$) of Other small states and Value added (constant 2005 US$) of Kyrgyz Republic?
Give a very brief answer. 2.30e+1. In the year 2006, what is the difference between the Value added (constant 2005 US$) of Egypt, Arab Rep. and Value added (constant 2005 US$) of Finland?
Your answer should be very brief. -3.13e+1. In the year 2006, what is the difference between the Value added (constant 2005 US$) of Egypt, Arab Rep. and Value added (constant 2005 US$) of Kyrgyz Republic?
Offer a very short reply. 3.34e+1. In the year 2006, what is the difference between the Value added (constant 2005 US$) in Finland and Value added (constant 2005 US$) in Kyrgyz Republic?
Keep it short and to the point. 6.47e+1. In the year 2007, what is the difference between the Value added (constant 2005 US$) of Other small states and Value added (constant 2005 US$) of Egypt, Arab Rep.?
Give a very brief answer. -1.15e+1. In the year 2007, what is the difference between the Value added (constant 2005 US$) in Other small states and Value added (constant 2005 US$) in Finland?
Your answer should be very brief. -4.58e+1. In the year 2007, what is the difference between the Value added (constant 2005 US$) of Other small states and Value added (constant 2005 US$) of Kyrgyz Republic?
Your answer should be very brief. 2.44e+1. In the year 2007, what is the difference between the Value added (constant 2005 US$) in Egypt, Arab Rep. and Value added (constant 2005 US$) in Finland?
Your response must be concise. -3.43e+1. In the year 2007, what is the difference between the Value added (constant 2005 US$) of Egypt, Arab Rep. and Value added (constant 2005 US$) of Kyrgyz Republic?
Offer a terse response. 3.59e+1. In the year 2007, what is the difference between the Value added (constant 2005 US$) in Finland and Value added (constant 2005 US$) in Kyrgyz Republic?
Provide a succinct answer. 7.01e+1. In the year 2008, what is the difference between the Value added (constant 2005 US$) in Other small states and Value added (constant 2005 US$) in Egypt, Arab Rep.?
Keep it short and to the point. -1.40e+1. In the year 2008, what is the difference between the Value added (constant 2005 US$) in Other small states and Value added (constant 2005 US$) in Finland?
Offer a terse response. -4.35e+1. In the year 2008, what is the difference between the Value added (constant 2005 US$) in Other small states and Value added (constant 2005 US$) in Kyrgyz Republic?
Give a very brief answer. 2.47e+1. In the year 2008, what is the difference between the Value added (constant 2005 US$) of Egypt, Arab Rep. and Value added (constant 2005 US$) of Finland?
Your answer should be very brief. -2.95e+1. In the year 2008, what is the difference between the Value added (constant 2005 US$) of Egypt, Arab Rep. and Value added (constant 2005 US$) of Kyrgyz Republic?
Ensure brevity in your answer.  3.87e+1. In the year 2008, what is the difference between the Value added (constant 2005 US$) of Finland and Value added (constant 2005 US$) of Kyrgyz Republic?
Provide a short and direct response. 6.82e+1. In the year 2009, what is the difference between the Value added (constant 2005 US$) in Other small states and Value added (constant 2005 US$) in Egypt, Arab Rep.?
Keep it short and to the point. -1.89e+1. In the year 2009, what is the difference between the Value added (constant 2005 US$) of Other small states and Value added (constant 2005 US$) of Finland?
Offer a terse response. -3.38e+1. In the year 2009, what is the difference between the Value added (constant 2005 US$) in Other small states and Value added (constant 2005 US$) in Kyrgyz Republic?
Give a very brief answer. 2.20e+1. In the year 2009, what is the difference between the Value added (constant 2005 US$) in Egypt, Arab Rep. and Value added (constant 2005 US$) in Finland?
Make the answer very short. -1.49e+1. In the year 2009, what is the difference between the Value added (constant 2005 US$) of Egypt, Arab Rep. and Value added (constant 2005 US$) of Kyrgyz Republic?
Your answer should be very brief. 4.09e+1. In the year 2009, what is the difference between the Value added (constant 2005 US$) of Finland and Value added (constant 2005 US$) of Kyrgyz Republic?
Make the answer very short. 5.58e+1. What is the ratio of the Value added (constant 2005 US$) of Other small states in 2003 to that in 2004?
Your answer should be compact. 0.98. What is the ratio of the Value added (constant 2005 US$) in Egypt, Arab Rep. in 2003 to that in 2004?
Offer a very short reply. 0.97. What is the ratio of the Value added (constant 2005 US$) in Finland in 2003 to that in 2004?
Offer a terse response. 0.95. What is the ratio of the Value added (constant 2005 US$) of Kyrgyz Republic in 2003 to that in 2004?
Offer a terse response. 0.97. What is the ratio of the Value added (constant 2005 US$) of Other small states in 2003 to that in 2005?
Provide a succinct answer. 0.96. What is the ratio of the Value added (constant 2005 US$) in Egypt, Arab Rep. in 2003 to that in 2005?
Your response must be concise. 0.94. What is the ratio of the Value added (constant 2005 US$) in Finland in 2003 to that in 2005?
Offer a terse response. 0.92. What is the ratio of the Value added (constant 2005 US$) in Kyrgyz Republic in 2003 to that in 2005?
Give a very brief answer. 1.08. What is the ratio of the Value added (constant 2005 US$) of Egypt, Arab Rep. in 2003 to that in 2006?
Offer a very short reply. 0.85. What is the ratio of the Value added (constant 2005 US$) of Finland in 2003 to that in 2006?
Your answer should be compact. 0.84. What is the ratio of the Value added (constant 2005 US$) of Kyrgyz Republic in 2003 to that in 2006?
Your response must be concise. 1.16. What is the ratio of the Value added (constant 2005 US$) of Other small states in 2003 to that in 2007?
Your answer should be compact. 0.91. What is the ratio of the Value added (constant 2005 US$) of Egypt, Arab Rep. in 2003 to that in 2007?
Offer a terse response. 0.79. What is the ratio of the Value added (constant 2005 US$) in Finland in 2003 to that in 2007?
Your response must be concise. 0.78. What is the ratio of the Value added (constant 2005 US$) in Kyrgyz Republic in 2003 to that in 2007?
Your answer should be very brief. 1.05. What is the ratio of the Value added (constant 2005 US$) of Other small states in 2003 to that in 2008?
Ensure brevity in your answer.  0.9. What is the ratio of the Value added (constant 2005 US$) of Egypt, Arab Rep. in 2003 to that in 2008?
Provide a succinct answer. 0.73. What is the ratio of the Value added (constant 2005 US$) in Finland in 2003 to that in 2008?
Make the answer very short. 0.8. What is the ratio of the Value added (constant 2005 US$) of Kyrgyz Republic in 2003 to that in 2008?
Your response must be concise. 0.92. What is the ratio of the Value added (constant 2005 US$) in Other small states in 2003 to that in 2009?
Your answer should be compact. 1.01. What is the ratio of the Value added (constant 2005 US$) in Egypt, Arab Rep. in 2003 to that in 2009?
Give a very brief answer. 0.69. What is the ratio of the Value added (constant 2005 US$) of Finland in 2003 to that in 2009?
Your response must be concise. 0.98. What is the ratio of the Value added (constant 2005 US$) in Kyrgyz Republic in 2003 to that in 2009?
Give a very brief answer. 0.92. What is the ratio of the Value added (constant 2005 US$) of Other small states in 2004 to that in 2005?
Your answer should be compact. 0.99. What is the ratio of the Value added (constant 2005 US$) of Egypt, Arab Rep. in 2004 to that in 2005?
Your response must be concise. 0.96. What is the ratio of the Value added (constant 2005 US$) in Finland in 2004 to that in 2005?
Your answer should be very brief. 0.96. What is the ratio of the Value added (constant 2005 US$) in Kyrgyz Republic in 2004 to that in 2005?
Keep it short and to the point. 1.11. What is the ratio of the Value added (constant 2005 US$) in Other small states in 2004 to that in 2006?
Make the answer very short. 0.99. What is the ratio of the Value added (constant 2005 US$) in Egypt, Arab Rep. in 2004 to that in 2006?
Provide a short and direct response. 0.87. What is the ratio of the Value added (constant 2005 US$) in Finland in 2004 to that in 2006?
Give a very brief answer. 0.89. What is the ratio of the Value added (constant 2005 US$) in Kyrgyz Republic in 2004 to that in 2006?
Ensure brevity in your answer.  1.19. What is the ratio of the Value added (constant 2005 US$) of Other small states in 2004 to that in 2007?
Ensure brevity in your answer.  0.94. What is the ratio of the Value added (constant 2005 US$) of Egypt, Arab Rep. in 2004 to that in 2007?
Offer a very short reply. 0.81. What is the ratio of the Value added (constant 2005 US$) in Finland in 2004 to that in 2007?
Offer a very short reply. 0.82. What is the ratio of the Value added (constant 2005 US$) in Kyrgyz Republic in 2004 to that in 2007?
Your answer should be very brief. 1.08. What is the ratio of the Value added (constant 2005 US$) of Other small states in 2004 to that in 2008?
Your answer should be very brief. 0.92. What is the ratio of the Value added (constant 2005 US$) in Egypt, Arab Rep. in 2004 to that in 2008?
Your response must be concise. 0.75. What is the ratio of the Value added (constant 2005 US$) in Finland in 2004 to that in 2008?
Give a very brief answer. 0.84. What is the ratio of the Value added (constant 2005 US$) in Kyrgyz Republic in 2004 to that in 2008?
Your response must be concise. 0.95. What is the ratio of the Value added (constant 2005 US$) of Other small states in 2004 to that in 2009?
Provide a succinct answer. 1.03. What is the ratio of the Value added (constant 2005 US$) of Egypt, Arab Rep. in 2004 to that in 2009?
Keep it short and to the point. 0.71. What is the ratio of the Value added (constant 2005 US$) in Finland in 2004 to that in 2009?
Offer a very short reply. 1.02. What is the ratio of the Value added (constant 2005 US$) in Kyrgyz Republic in 2004 to that in 2009?
Offer a very short reply. 0.95. What is the ratio of the Value added (constant 2005 US$) in Other small states in 2005 to that in 2006?
Keep it short and to the point. 1. What is the ratio of the Value added (constant 2005 US$) of Egypt, Arab Rep. in 2005 to that in 2006?
Keep it short and to the point. 0.9. What is the ratio of the Value added (constant 2005 US$) of Finland in 2005 to that in 2006?
Ensure brevity in your answer.  0.92. What is the ratio of the Value added (constant 2005 US$) in Kyrgyz Republic in 2005 to that in 2006?
Give a very brief answer. 1.08. What is the ratio of the Value added (constant 2005 US$) of Other small states in 2005 to that in 2007?
Provide a short and direct response. 0.95. What is the ratio of the Value added (constant 2005 US$) in Egypt, Arab Rep. in 2005 to that in 2007?
Your response must be concise. 0.84. What is the ratio of the Value added (constant 2005 US$) in Finland in 2005 to that in 2007?
Offer a very short reply. 0.85. What is the ratio of the Value added (constant 2005 US$) in Kyrgyz Republic in 2005 to that in 2007?
Provide a succinct answer. 0.98. What is the ratio of the Value added (constant 2005 US$) in Other small states in 2005 to that in 2008?
Offer a very short reply. 0.93. What is the ratio of the Value added (constant 2005 US$) of Egypt, Arab Rep. in 2005 to that in 2008?
Offer a very short reply. 0.78. What is the ratio of the Value added (constant 2005 US$) in Finland in 2005 to that in 2008?
Offer a very short reply. 0.87. What is the ratio of the Value added (constant 2005 US$) of Kyrgyz Republic in 2005 to that in 2008?
Make the answer very short. 0.86. What is the ratio of the Value added (constant 2005 US$) in Other small states in 2005 to that in 2009?
Your answer should be very brief. 1.04. What is the ratio of the Value added (constant 2005 US$) in Egypt, Arab Rep. in 2005 to that in 2009?
Your response must be concise. 0.74. What is the ratio of the Value added (constant 2005 US$) of Finland in 2005 to that in 2009?
Provide a succinct answer. 1.06. What is the ratio of the Value added (constant 2005 US$) of Kyrgyz Republic in 2005 to that in 2009?
Keep it short and to the point. 0.86. What is the ratio of the Value added (constant 2005 US$) in Other small states in 2006 to that in 2007?
Make the answer very short. 0.95. What is the ratio of the Value added (constant 2005 US$) of Egypt, Arab Rep. in 2006 to that in 2007?
Your response must be concise. 0.93. What is the ratio of the Value added (constant 2005 US$) of Finland in 2006 to that in 2007?
Your response must be concise. 0.92. What is the ratio of the Value added (constant 2005 US$) in Kyrgyz Republic in 2006 to that in 2007?
Your response must be concise. 0.91. What is the ratio of the Value added (constant 2005 US$) of Other small states in 2006 to that in 2008?
Your answer should be very brief. 0.93. What is the ratio of the Value added (constant 2005 US$) of Egypt, Arab Rep. in 2006 to that in 2008?
Your answer should be very brief. 0.86. What is the ratio of the Value added (constant 2005 US$) of Finland in 2006 to that in 2008?
Your answer should be compact. 0.95. What is the ratio of the Value added (constant 2005 US$) of Kyrgyz Republic in 2006 to that in 2008?
Keep it short and to the point. 0.8. What is the ratio of the Value added (constant 2005 US$) in Other small states in 2006 to that in 2009?
Offer a very short reply. 1.04. What is the ratio of the Value added (constant 2005 US$) in Egypt, Arab Rep. in 2006 to that in 2009?
Offer a very short reply. 0.82. What is the ratio of the Value added (constant 2005 US$) in Finland in 2006 to that in 2009?
Keep it short and to the point. 1.16. What is the ratio of the Value added (constant 2005 US$) of Kyrgyz Republic in 2006 to that in 2009?
Your response must be concise. 0.8. What is the ratio of the Value added (constant 2005 US$) in Other small states in 2007 to that in 2008?
Ensure brevity in your answer.  0.98. What is the ratio of the Value added (constant 2005 US$) of Egypt, Arab Rep. in 2007 to that in 2008?
Offer a terse response. 0.93. What is the ratio of the Value added (constant 2005 US$) of Finland in 2007 to that in 2008?
Offer a terse response. 1.03. What is the ratio of the Value added (constant 2005 US$) in Kyrgyz Republic in 2007 to that in 2008?
Your answer should be compact. 0.88. What is the ratio of the Value added (constant 2005 US$) in Other small states in 2007 to that in 2009?
Make the answer very short. 1.1. What is the ratio of the Value added (constant 2005 US$) in Egypt, Arab Rep. in 2007 to that in 2009?
Offer a very short reply. 0.88. What is the ratio of the Value added (constant 2005 US$) in Finland in 2007 to that in 2009?
Offer a terse response. 1.25. What is the ratio of the Value added (constant 2005 US$) in Kyrgyz Republic in 2007 to that in 2009?
Your answer should be very brief. 0.88. What is the ratio of the Value added (constant 2005 US$) of Other small states in 2008 to that in 2009?
Make the answer very short. 1.12. What is the ratio of the Value added (constant 2005 US$) of Finland in 2008 to that in 2009?
Your response must be concise. 1.22. What is the ratio of the Value added (constant 2005 US$) of Kyrgyz Republic in 2008 to that in 2009?
Keep it short and to the point. 1. What is the difference between the highest and the second highest Value added (constant 2005 US$) of Other small states?
Offer a very short reply. 4.36e+08. What is the difference between the highest and the second highest Value added (constant 2005 US$) of Egypt, Arab Rep.?
Ensure brevity in your answer.  2.18e+09. What is the difference between the highest and the second highest Value added (constant 2005 US$) of Finland?
Provide a short and direct response. 1.83e+09. What is the difference between the highest and the second highest Value added (constant 2005 US$) of Kyrgyz Republic?
Give a very brief answer. 1.82e+06. What is the difference between the highest and the lowest Value added (constant 2005 US$) in Other small states?
Keep it short and to the point. 2.74e+09. What is the difference between the highest and the lowest Value added (constant 2005 US$) of Egypt, Arab Rep.?
Provide a succinct answer. 1.28e+1. What is the difference between the highest and the lowest Value added (constant 2005 US$) in Finland?
Offer a very short reply. 1.56e+1. What is the difference between the highest and the lowest Value added (constant 2005 US$) of Kyrgyz Republic?
Provide a succinct answer. 1.17e+08. 